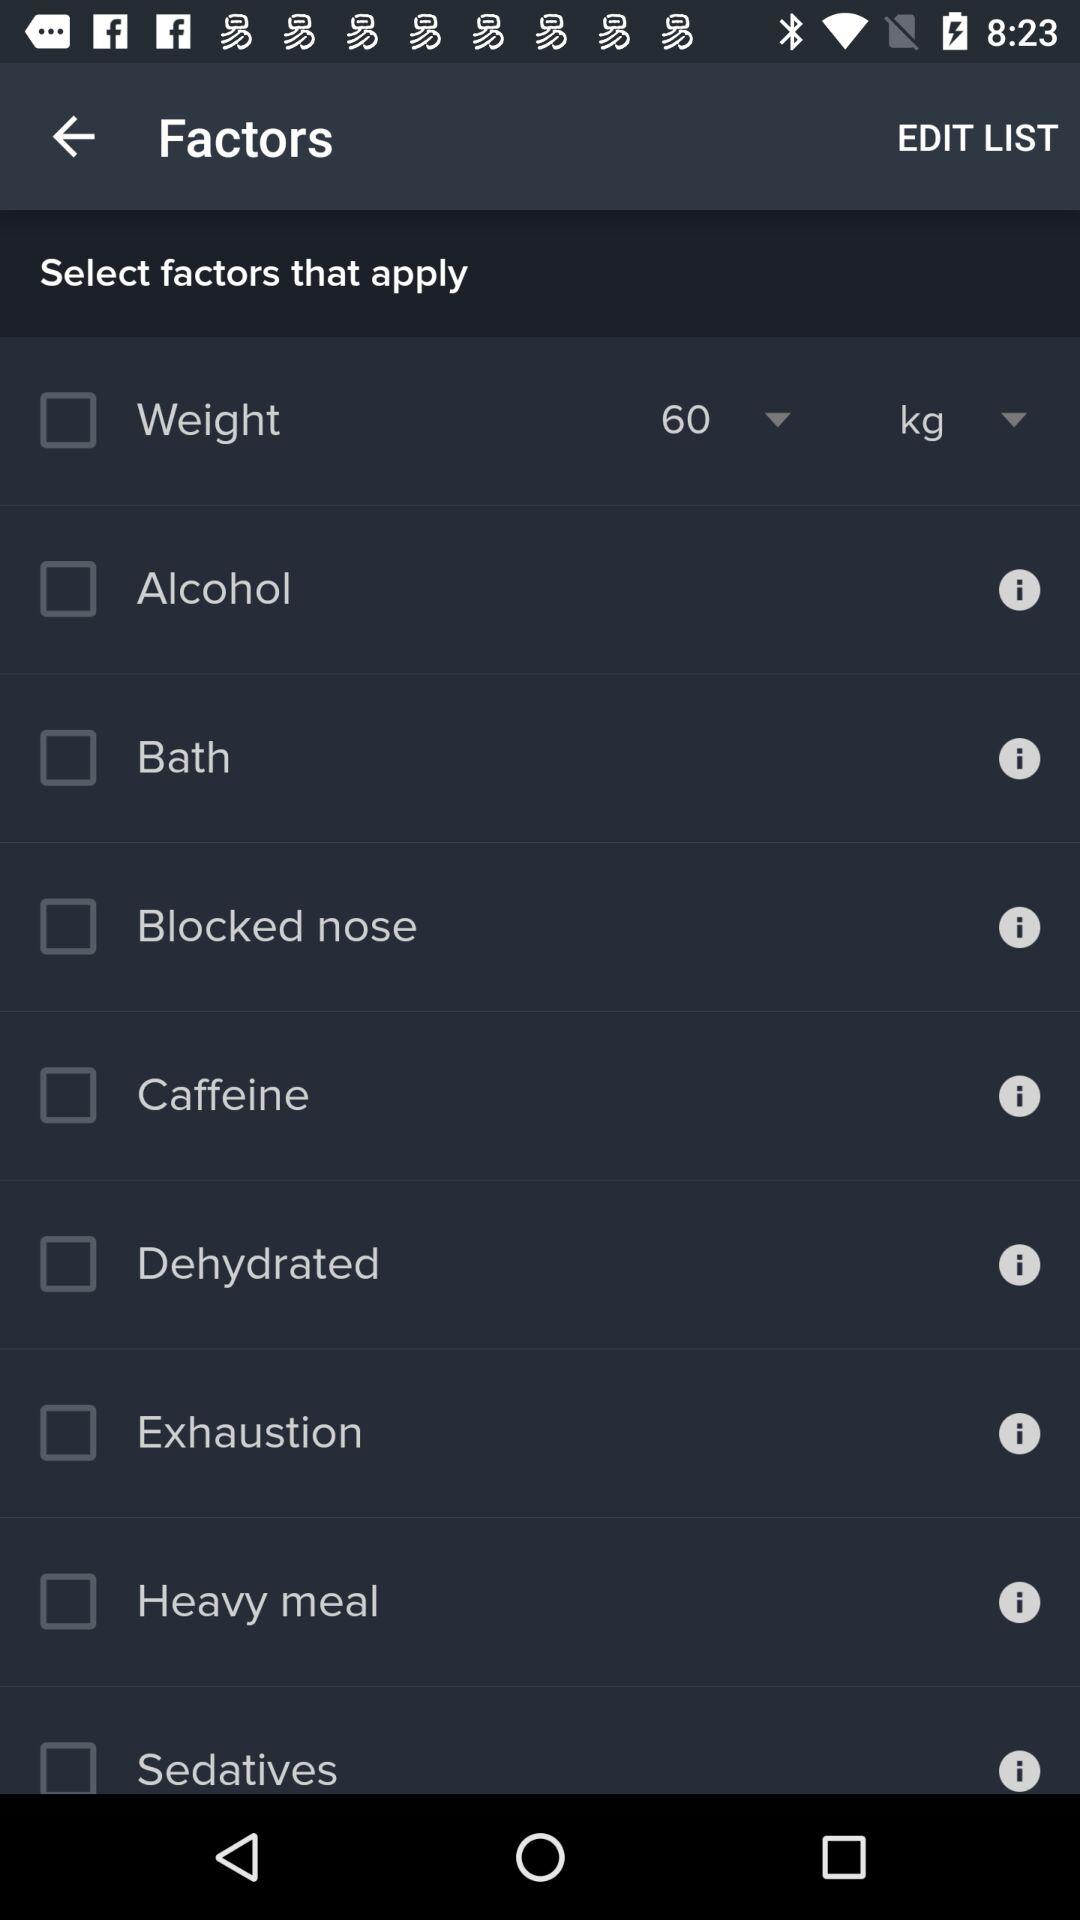What is the current status of "Bath"? The current status of "Bath" is "off". 